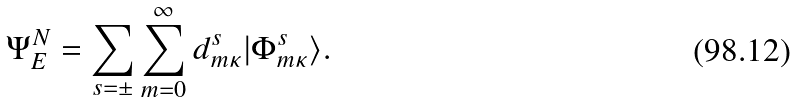Convert formula to latex. <formula><loc_0><loc_0><loc_500><loc_500>\Psi ^ { N } _ { E } = \sum _ { s = \pm } \sum _ { m = 0 } ^ { \infty } d _ { m \kappa } ^ { s } | \Phi _ { m \kappa } ^ { s } \rangle .</formula> 